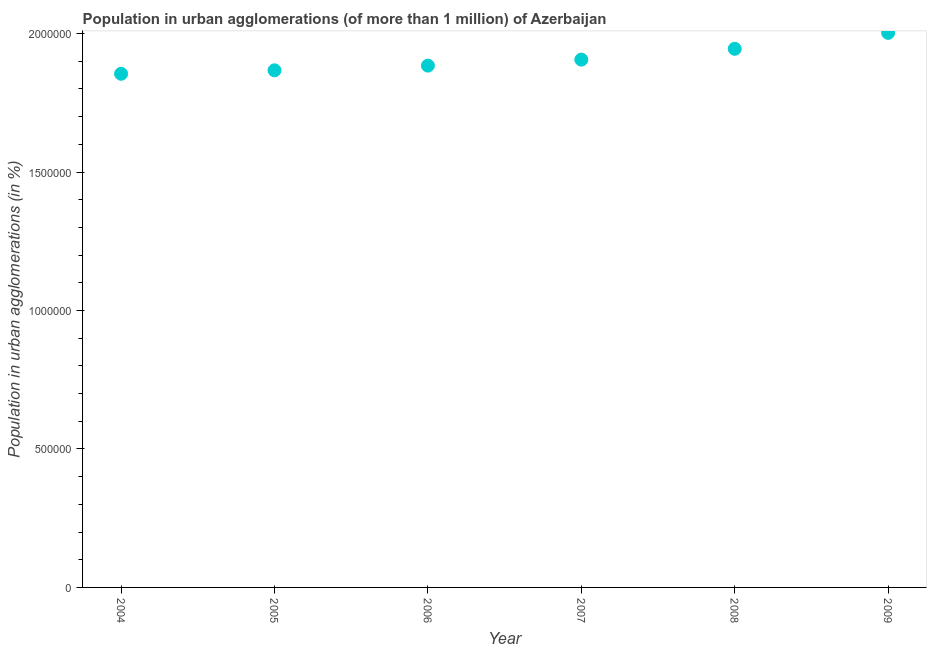What is the population in urban agglomerations in 2006?
Your response must be concise. 1.88e+06. Across all years, what is the maximum population in urban agglomerations?
Your answer should be compact. 2.00e+06. Across all years, what is the minimum population in urban agglomerations?
Your answer should be very brief. 1.85e+06. What is the sum of the population in urban agglomerations?
Offer a very short reply. 1.15e+07. What is the difference between the population in urban agglomerations in 2005 and 2006?
Provide a short and direct response. -1.70e+04. What is the average population in urban agglomerations per year?
Keep it short and to the point. 1.91e+06. What is the median population in urban agglomerations?
Offer a very short reply. 1.90e+06. What is the ratio of the population in urban agglomerations in 2004 to that in 2008?
Provide a succinct answer. 0.95. Is the population in urban agglomerations in 2006 less than that in 2009?
Your answer should be very brief. Yes. Is the difference between the population in urban agglomerations in 2004 and 2006 greater than the difference between any two years?
Give a very brief answer. No. What is the difference between the highest and the second highest population in urban agglomerations?
Ensure brevity in your answer.  5.75e+04. What is the difference between the highest and the lowest population in urban agglomerations?
Provide a short and direct response. 1.48e+05. In how many years, is the population in urban agglomerations greater than the average population in urban agglomerations taken over all years?
Your answer should be compact. 2. Does the population in urban agglomerations monotonically increase over the years?
Your answer should be compact. Yes. Are the values on the major ticks of Y-axis written in scientific E-notation?
Provide a short and direct response. No. Does the graph contain any zero values?
Give a very brief answer. No. What is the title of the graph?
Offer a terse response. Population in urban agglomerations (of more than 1 million) of Azerbaijan. What is the label or title of the Y-axis?
Keep it short and to the point. Population in urban agglomerations (in %). What is the Population in urban agglomerations (in %) in 2004?
Your answer should be very brief. 1.85e+06. What is the Population in urban agglomerations (in %) in 2005?
Your answer should be compact. 1.87e+06. What is the Population in urban agglomerations (in %) in 2006?
Your response must be concise. 1.88e+06. What is the Population in urban agglomerations (in %) in 2007?
Ensure brevity in your answer.  1.91e+06. What is the Population in urban agglomerations (in %) in 2008?
Your answer should be very brief. 1.95e+06. What is the Population in urban agglomerations (in %) in 2009?
Give a very brief answer. 2.00e+06. What is the difference between the Population in urban agglomerations (in %) in 2004 and 2005?
Provide a short and direct response. -1.24e+04. What is the difference between the Population in urban agglomerations (in %) in 2004 and 2006?
Give a very brief answer. -2.94e+04. What is the difference between the Population in urban agglomerations (in %) in 2004 and 2007?
Your answer should be very brief. -5.11e+04. What is the difference between the Population in urban agglomerations (in %) in 2004 and 2008?
Provide a short and direct response. -9.01e+04. What is the difference between the Population in urban agglomerations (in %) in 2004 and 2009?
Your response must be concise. -1.48e+05. What is the difference between the Population in urban agglomerations (in %) in 2005 and 2006?
Ensure brevity in your answer.  -1.70e+04. What is the difference between the Population in urban agglomerations (in %) in 2005 and 2007?
Your answer should be compact. -3.87e+04. What is the difference between the Population in urban agglomerations (in %) in 2005 and 2008?
Provide a succinct answer. -7.77e+04. What is the difference between the Population in urban agglomerations (in %) in 2005 and 2009?
Your answer should be very brief. -1.35e+05. What is the difference between the Population in urban agglomerations (in %) in 2006 and 2007?
Offer a terse response. -2.17e+04. What is the difference between the Population in urban agglomerations (in %) in 2006 and 2008?
Make the answer very short. -6.08e+04. What is the difference between the Population in urban agglomerations (in %) in 2006 and 2009?
Make the answer very short. -1.18e+05. What is the difference between the Population in urban agglomerations (in %) in 2007 and 2008?
Your answer should be very brief. -3.91e+04. What is the difference between the Population in urban agglomerations (in %) in 2007 and 2009?
Offer a terse response. -9.66e+04. What is the difference between the Population in urban agglomerations (in %) in 2008 and 2009?
Offer a terse response. -5.75e+04. What is the ratio of the Population in urban agglomerations (in %) in 2004 to that in 2008?
Ensure brevity in your answer.  0.95. What is the ratio of the Population in urban agglomerations (in %) in 2004 to that in 2009?
Offer a terse response. 0.93. What is the ratio of the Population in urban agglomerations (in %) in 2005 to that in 2008?
Ensure brevity in your answer.  0.96. What is the ratio of the Population in urban agglomerations (in %) in 2005 to that in 2009?
Provide a short and direct response. 0.93. What is the ratio of the Population in urban agglomerations (in %) in 2006 to that in 2009?
Your response must be concise. 0.94. What is the ratio of the Population in urban agglomerations (in %) in 2007 to that in 2009?
Make the answer very short. 0.95. What is the ratio of the Population in urban agglomerations (in %) in 2008 to that in 2009?
Your response must be concise. 0.97. 